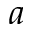Convert formula to latex. <formula><loc_0><loc_0><loc_500><loc_500>a</formula> 